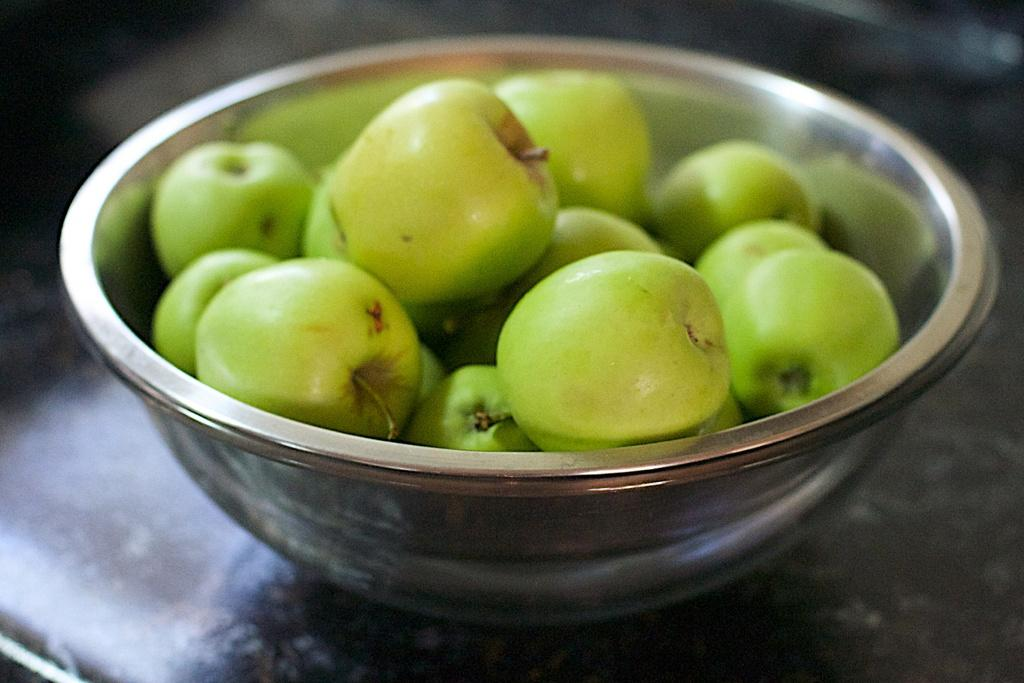What type of bowl is in the image? There is a steel bowl in the image. What is inside the bowl? The bowl contains fruits. Where is the bowl located? The bowl is placed on a platform. How many icicles are hanging from the front of the bowl in the image? There are no icicles present in the image, as it features a steel bowl containing fruits on a platform. 